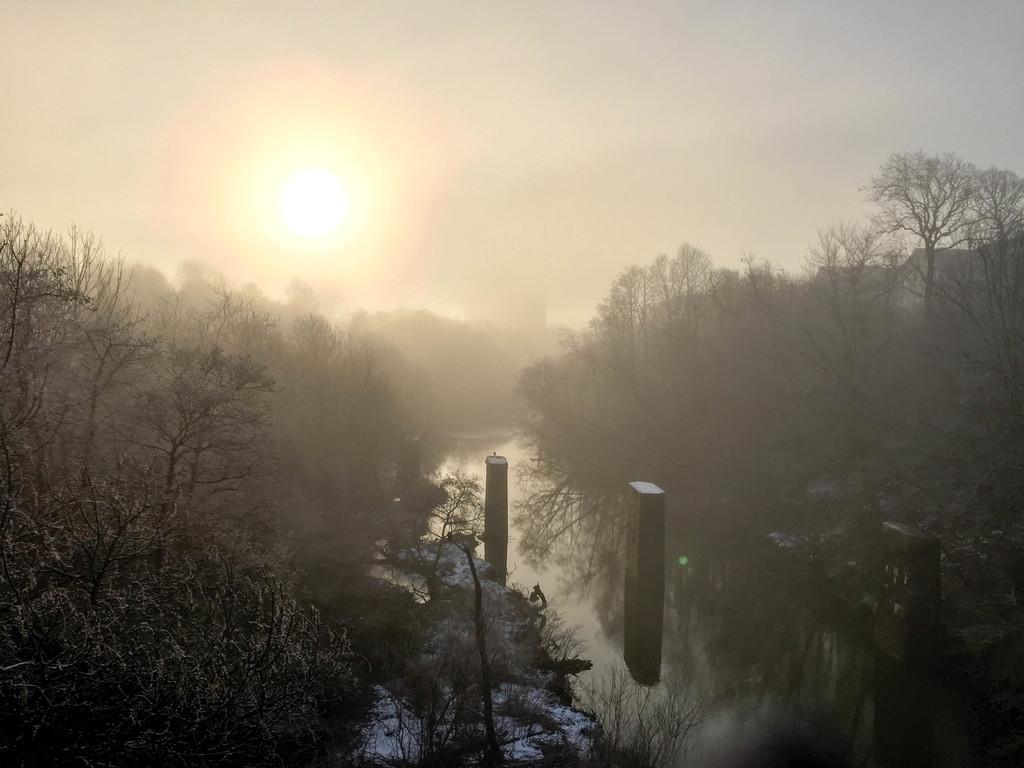How would you summarize this image in a sentence or two? In this image there is the water flowing in the center. There are blocks in the water. On the either sides of the image there are trees. At the top there is the sky. There is the sun in the sky. 